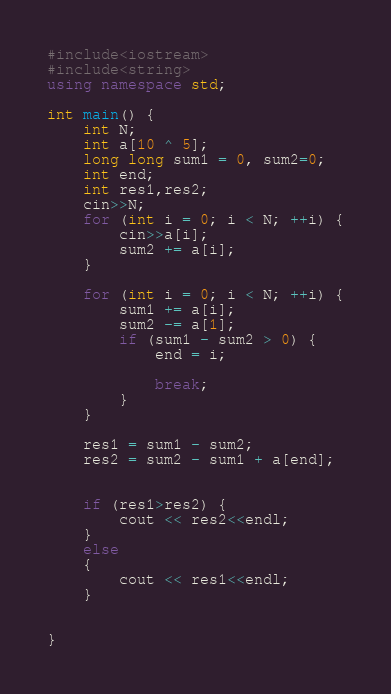Convert code to text. <code><loc_0><loc_0><loc_500><loc_500><_C++_>#include<iostream>
#include<string>
using namespace std;

int main() {
	int N;
	int a[10 ^ 5];
	long long sum1 = 0, sum2=0;
	int end;
	int res1,res2;
	cin>>N;
	for (int i = 0; i < N; ++i) {
		cin>>a[i];
		sum2 += a[i];
	}

	for (int i = 0; i < N; ++i) {
		sum1 += a[i];
		sum2 -= a[1];
		if (sum1 - sum2 > 0) {
			end = i;
			
			break;
		}
	}

	res1 = sum1 - sum2;
	res2 = sum2 - sum1 + a[end];


	if (res1>res2) {
		cout << res2<<endl;
	}
	else
	{
		cout << res1<<endl;
	}

	
}</code> 